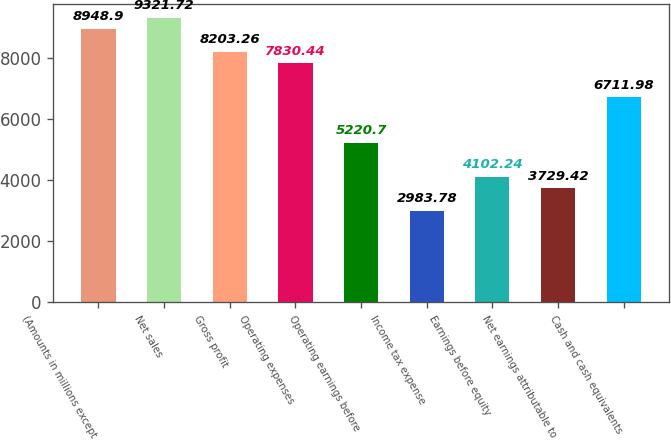Convert chart. <chart><loc_0><loc_0><loc_500><loc_500><bar_chart><fcel>(Amounts in millions except<fcel>Net sales<fcel>Gross profit<fcel>Operating expenses<fcel>Operating earnings before<fcel>Income tax expense<fcel>Earnings before equity<fcel>Net earnings attributable to<fcel>Cash and cash equivalents<nl><fcel>8948.9<fcel>9321.72<fcel>8203.26<fcel>7830.44<fcel>5220.7<fcel>2983.78<fcel>4102.24<fcel>3729.42<fcel>6711.98<nl></chart> 